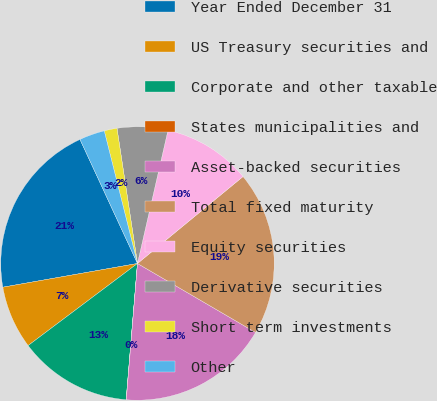Convert chart to OTSL. <chart><loc_0><loc_0><loc_500><loc_500><pie_chart><fcel>Year Ended December 31<fcel>US Treasury securities and<fcel>Corporate and other taxable<fcel>States municipalities and<fcel>Asset-backed securities<fcel>Total fixed maturity<fcel>Equity securities<fcel>Derivative securities<fcel>Short term investments<fcel>Other<nl><fcel>20.87%<fcel>7.47%<fcel>13.43%<fcel>0.02%<fcel>17.89%<fcel>19.38%<fcel>10.45%<fcel>5.98%<fcel>1.51%<fcel>3.0%<nl></chart> 